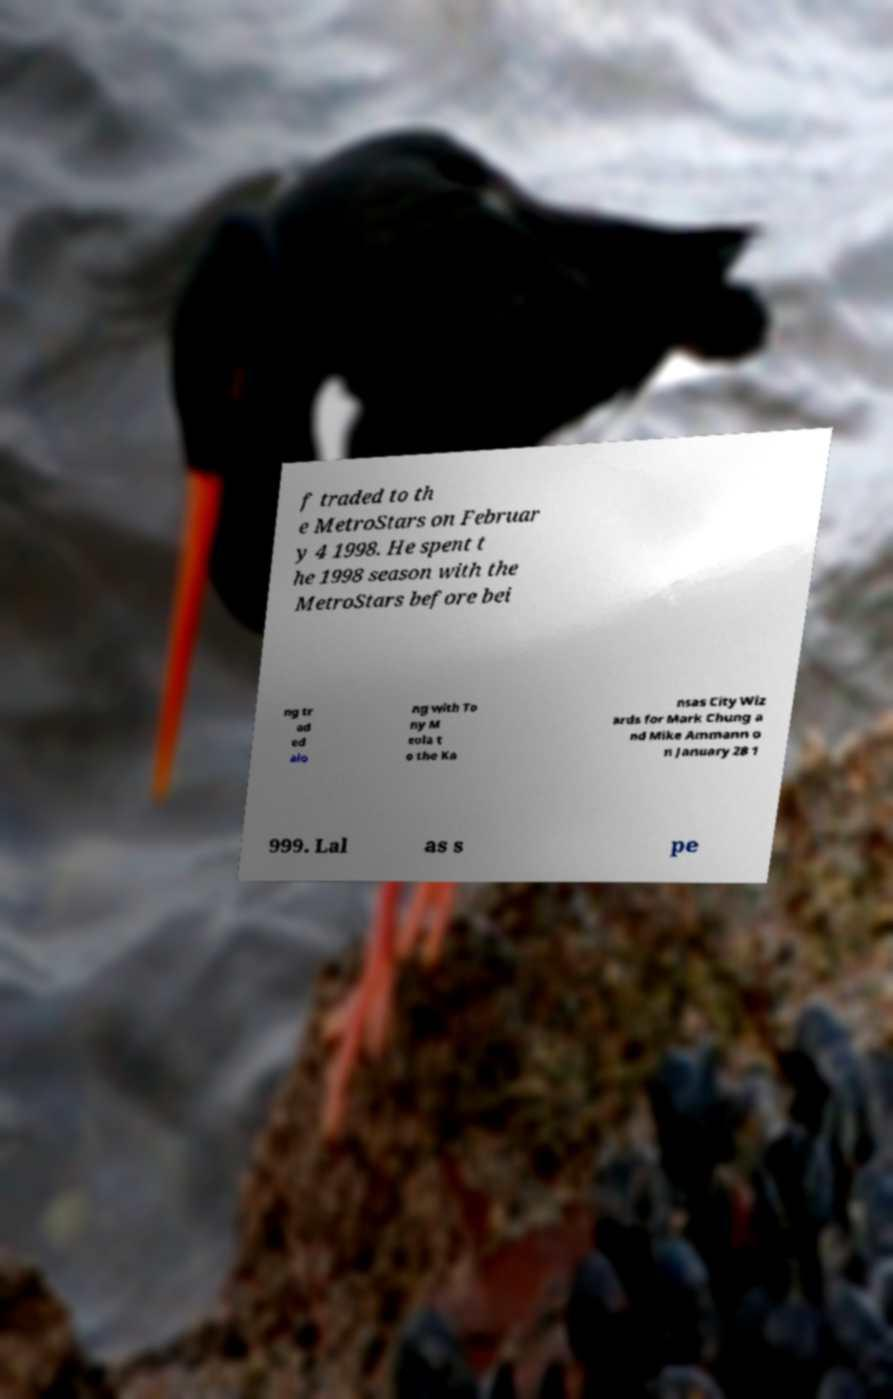Can you accurately transcribe the text from the provided image for me? f traded to th e MetroStars on Februar y 4 1998. He spent t he 1998 season with the MetroStars before bei ng tr ad ed alo ng with To ny M eola t o the Ka nsas City Wiz ards for Mark Chung a nd Mike Ammann o n January 28 1 999. Lal as s pe 